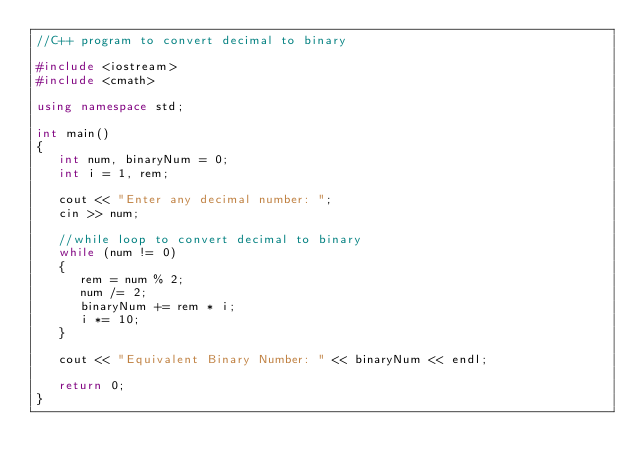<code> <loc_0><loc_0><loc_500><loc_500><_C++_>//C++ program to convert decimal to binary

#include <iostream>
#include <cmath>

using namespace std;

int main()
{
   int num, binaryNum = 0;
   int i = 1, rem;

   cout << "Enter any decimal number: ";
   cin >> num;

   //while loop to convert decimal to binary
   while (num != 0)
   {
      rem = num % 2;
      num /= 2;
      binaryNum += rem * i;
      i *= 10;
   }

   cout << "Equivalent Binary Number: " << binaryNum << endl;

   return 0;
}</code> 